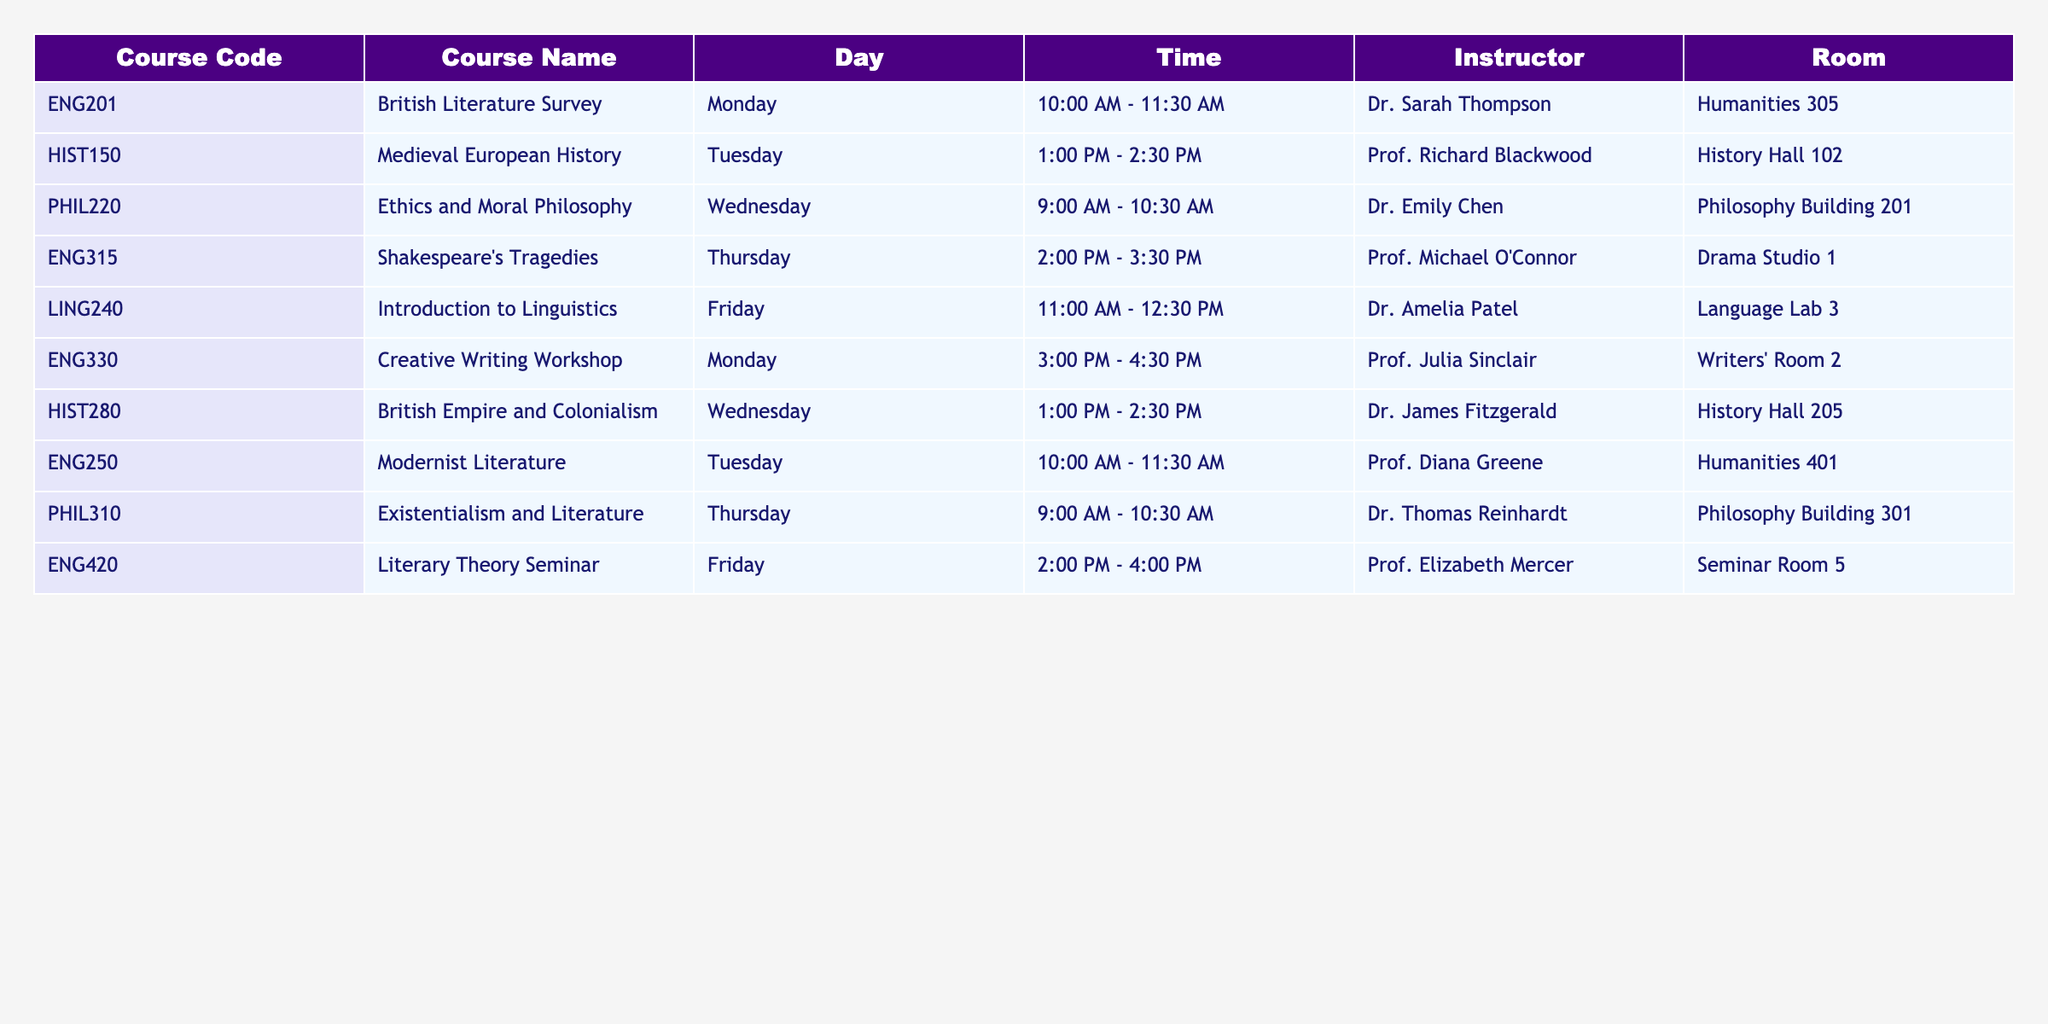What course does Dr. Emily Chen teach? Dr. Emily Chen is listed as the instructor for the course PHIL220, which is titled "Ethics and Moral Philosophy."
Answer: Ethics and Moral Philosophy Which course is scheduled on Tuesday at 1:00 PM? The course HIST150, "Medieval European History," is scheduled on Tuesday from 1:00 PM to 2:30 PM.
Answer: Medieval European History How many courses does Clare have on Mondays? Clare has two courses scheduled on Monday: ENG201 from 10:00 AM to 11:30 AM and ENG330 from 3:00 PM to 4:30 PM.
Answer: 2 What is the time slot for Shakespeare's Tragedies? The course ENG315, "Shakespeare's Tragedies," takes place on Thursday from 2:00 PM to 3:30 PM.
Answer: 2:00 PM - 3:30 PM Is there a course related to linguistics? Yes, there is a course titled LING240, "Introduction to Linguistics," which is scheduled on Friday from 11:00 AM to 12:30 PM.
Answer: Yes What is the average duration of the courses listed? Each course listed has a duration of 1.5 hours (90 minutes), calculated by finding the difference between the start and end times for each course. Since all are the same, the average is also 1.5 hours.
Answer: 1.5 hours Which course is the latest on Fridays? The course ENG420, "Literary Theory Seminar," is the latest on Friday, scheduled from 2:00 PM to 4:00 PM.
Answer: Literary Theory Seminar How many courses have "Philosophy" in their title? There are two courses with "Philosophy" in the title: PHIL220 (Ethics and Moral Philosophy) and PHIL310 (Existentialism and Literature).
Answer: 2 What room is the British Literature Survey held in? The course ENG201, "British Literature Survey," is held in Humanities 305.
Answer: Humanities 305 